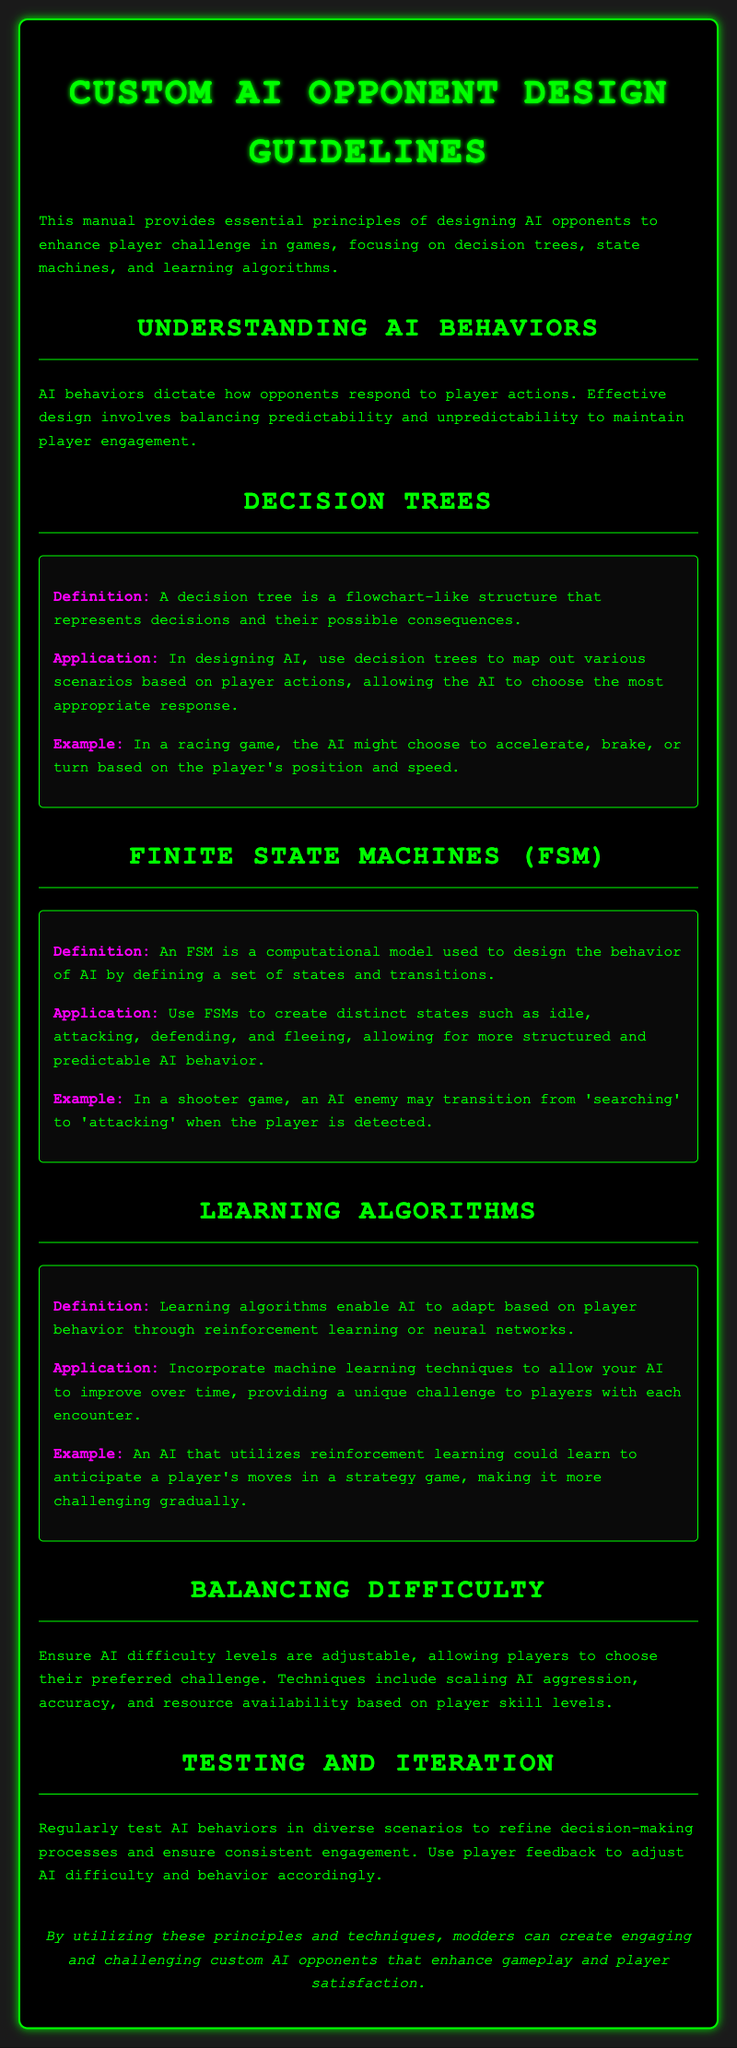What is the title of the manual? The title is stated at the top of the document, which is "Custom AI Opponent Design Guidelines."
Answer: Custom AI Opponent Design Guidelines What does AI behavior dictate? The document describes that AI behaviors dictate how opponents respond to player actions.
Answer: Opponent responses What is a decision tree? The document defines a decision tree as a flowchart-like structure that represents decisions and their possible consequences.
Answer: Flowchart-like structure Name an application of finite state machines. The manual mentions that finite state machines can create distinct states such as idle, attacking, defending, and fleeing.
Answer: Distinct states What should be adjustable to balance difficulty? The document highlights that AI difficulty levels should be adjustable based on player skill levels.
Answer: AI difficulty levels What does reinforcement learning enable? According to the document, reinforcement learning enables AI to adapt based on player behavior.
Answer: Adaptation to behavior How should AI behaviors be tested? The manual states that AI behaviors should be tested regularly in diverse scenarios.
Answer: Regular testing What is one example of a learning algorithm application? The document provides the example of an AI that utilizes reinforcement learning to anticipate a player's moves.
Answer: Anticipate a player's moves 